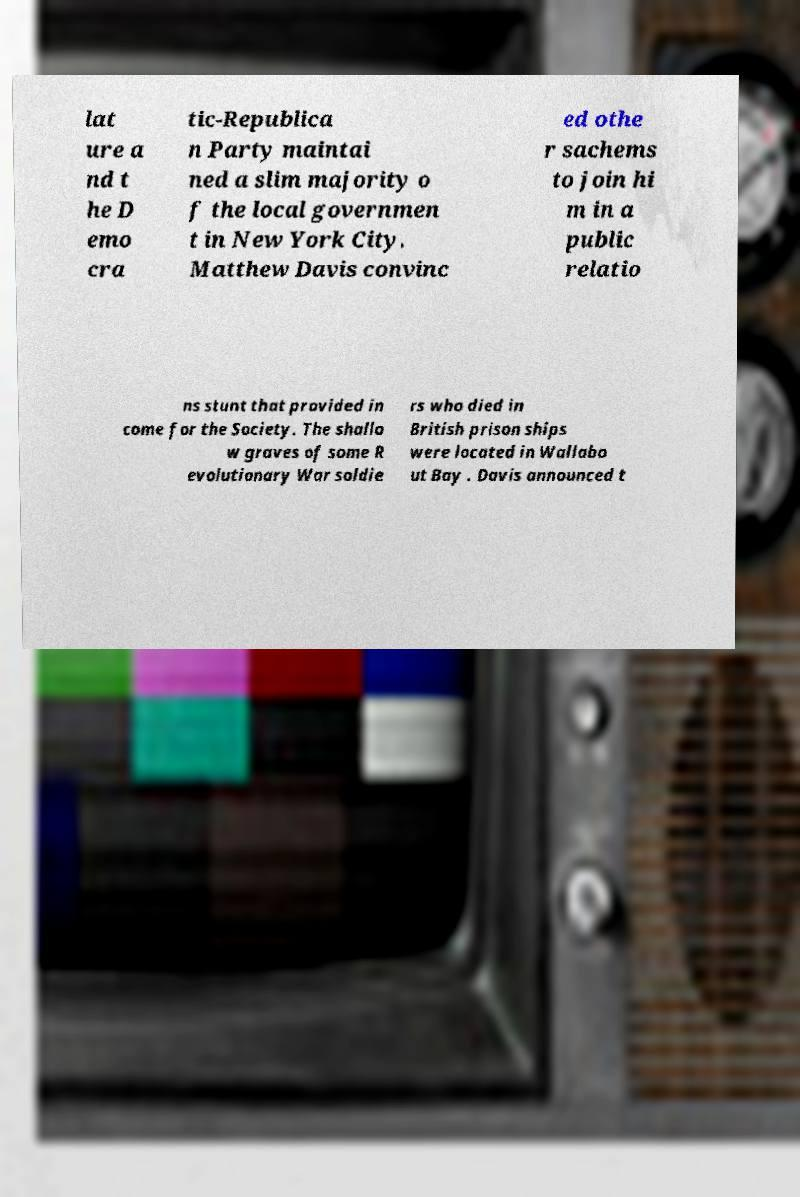There's text embedded in this image that I need extracted. Can you transcribe it verbatim? lat ure a nd t he D emo cra tic-Republica n Party maintai ned a slim majority o f the local governmen t in New York City. Matthew Davis convinc ed othe r sachems to join hi m in a public relatio ns stunt that provided in come for the Society. The shallo w graves of some R evolutionary War soldie rs who died in British prison ships were located in Wallabo ut Bay . Davis announced t 